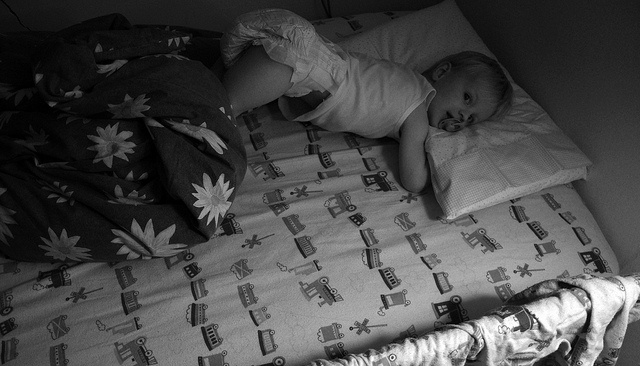Describe the objects in this image and their specific colors. I can see bed in black, gray, darkgray, and lightgray tones and people in gray and black tones in this image. 